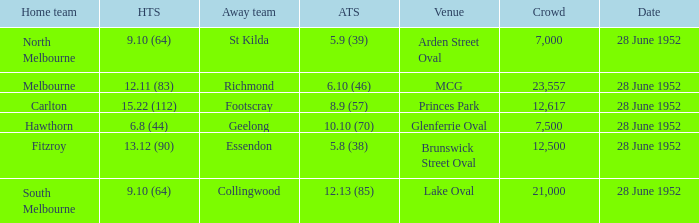Who is the away side when north melbourne is at home and has a score of 9.10 (64)? St Kilda. Would you mind parsing the complete table? {'header': ['Home team', 'HTS', 'Away team', 'ATS', 'Venue', 'Crowd', 'Date'], 'rows': [['North Melbourne', '9.10 (64)', 'St Kilda', '5.9 (39)', 'Arden Street Oval', '7,000', '28 June 1952'], ['Melbourne', '12.11 (83)', 'Richmond', '6.10 (46)', 'MCG', '23,557', '28 June 1952'], ['Carlton', '15.22 (112)', 'Footscray', '8.9 (57)', 'Princes Park', '12,617', '28 June 1952'], ['Hawthorn', '6.8 (44)', 'Geelong', '10.10 (70)', 'Glenferrie Oval', '7,500', '28 June 1952'], ['Fitzroy', '13.12 (90)', 'Essendon', '5.8 (38)', 'Brunswick Street Oval', '12,500', '28 June 1952'], ['South Melbourne', '9.10 (64)', 'Collingwood', '12.13 (85)', 'Lake Oval', '21,000', '28 June 1952']]} 